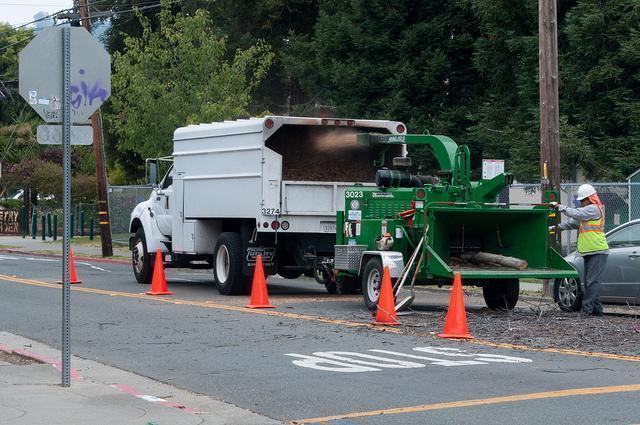How were the purple characters written?
Pick the right solution, then justify: 'Answer: answer
Rationale: rationale.'
Options: Spray can, paintbrush, crayon, pen. Answer: spray can.
Rationale: The man was using a can. 